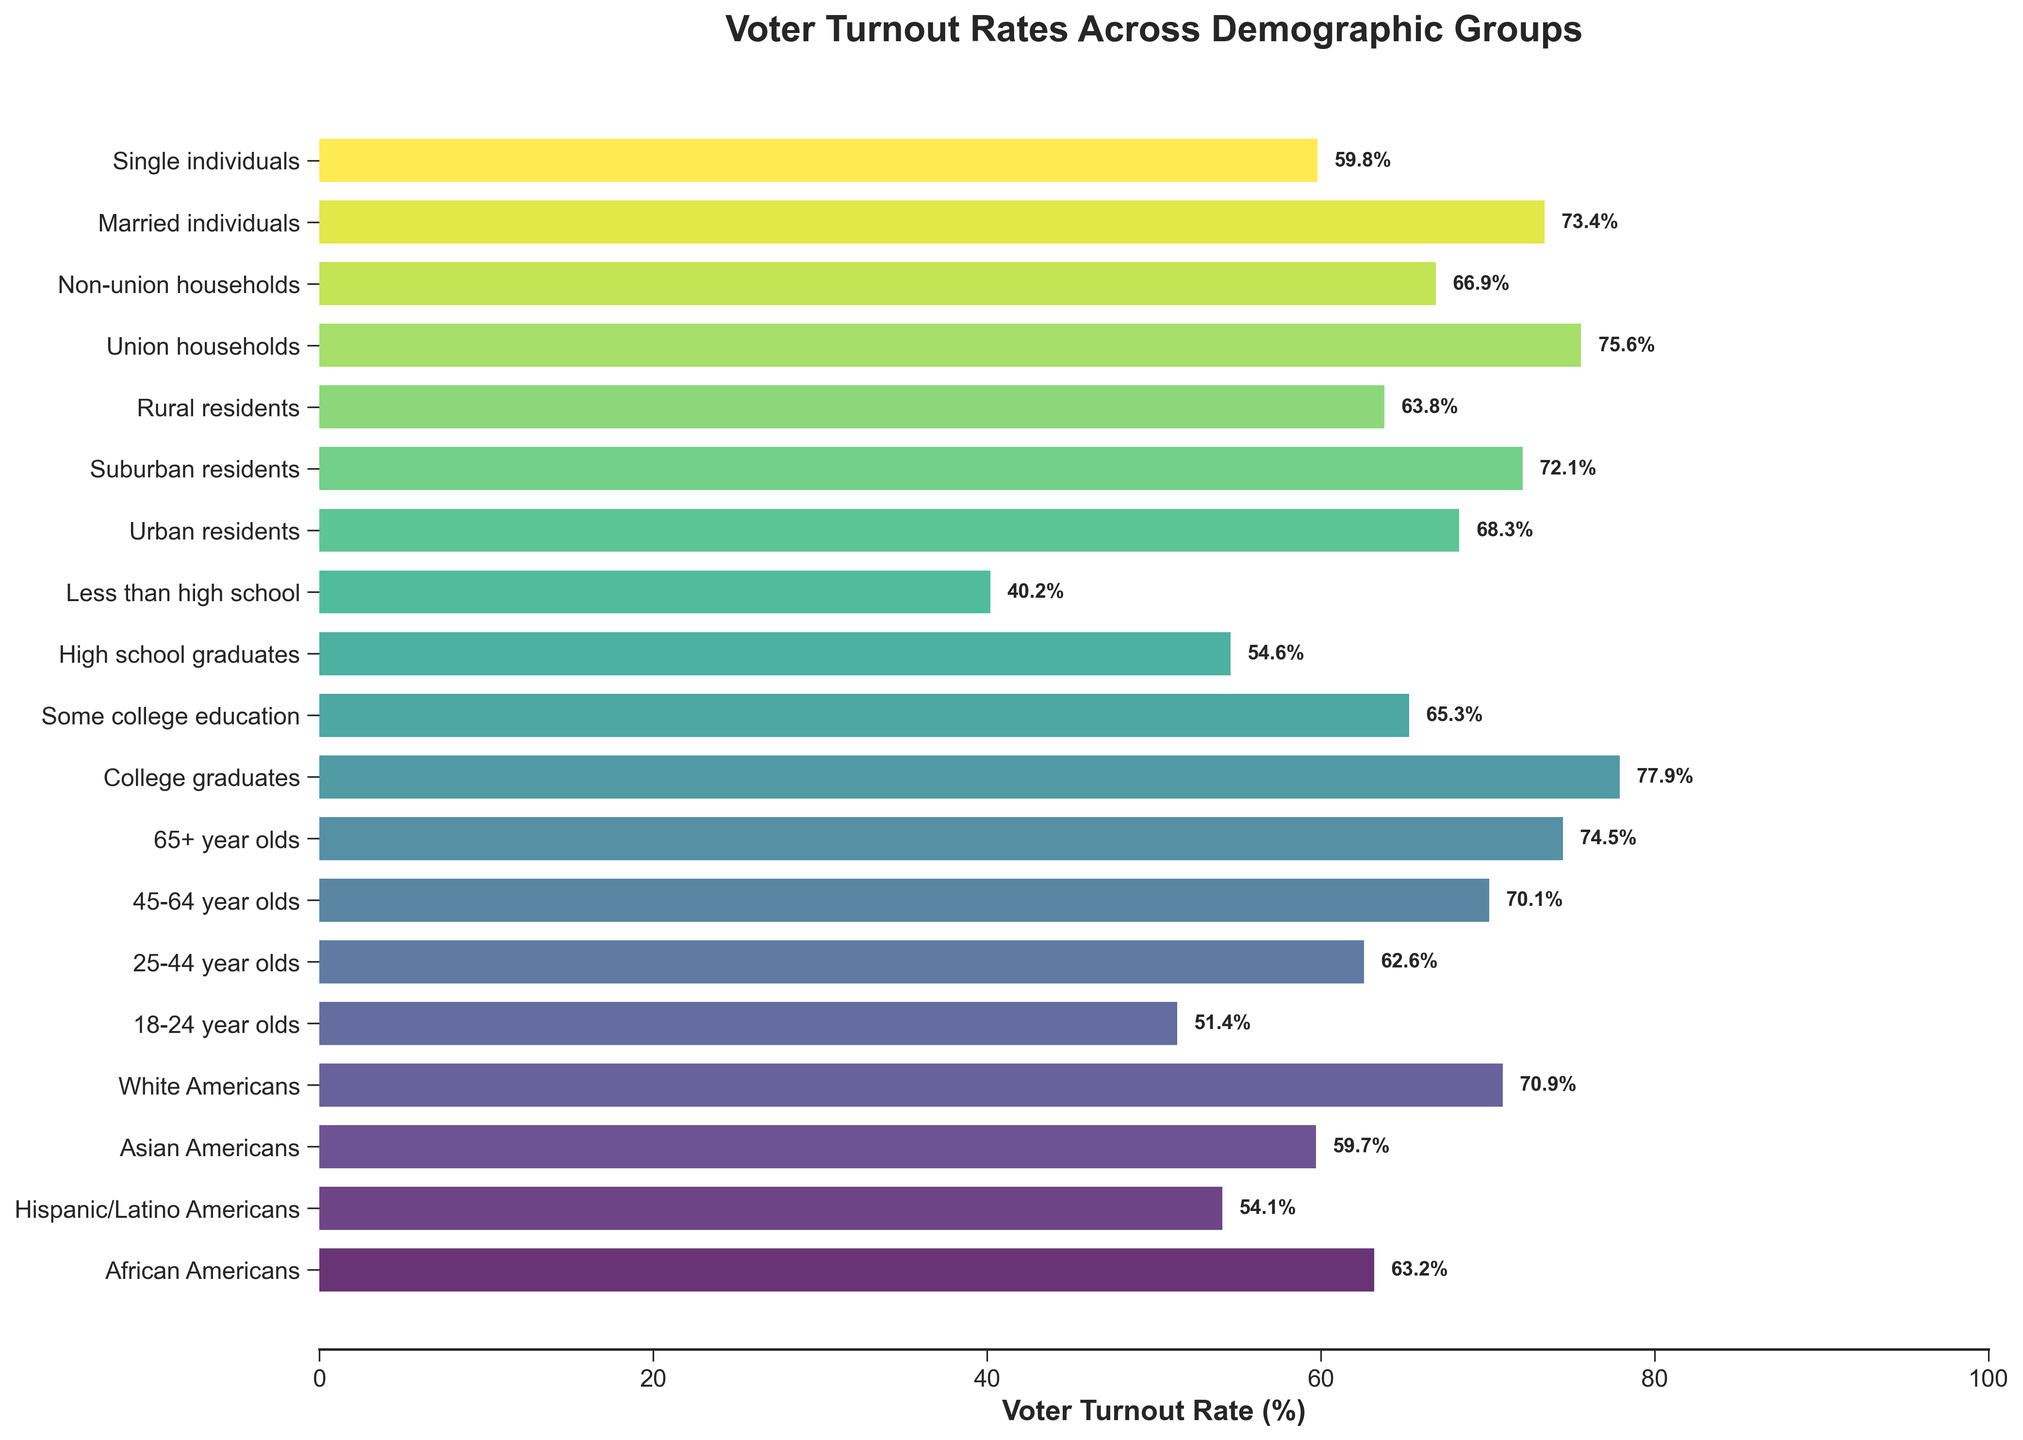What demographic group has the highest voter turnout rate? The bar representing "College graduates" is the longest, extending to 77.9%.
Answer: College graduates Which two demographic groups have the lowest voter turnout rates? The bars representing "Less than high school" and "18-24 year olds" are the shortest, extending to 40.2% and 51.4%, respectively.
Answer: Less than high school, 18-24 year olds What is the difference in voter turnout rate between African Americans and White Americans? The bar for African Americans has a length of 63.2%, and the bar for White Americans has a length of 70.9%. The difference is 70.9% - 63.2% = 7.7%.
Answer: 7.7% What is the average voter turnout rate of all groups? Sum all the voter turnout rates and divide by the number of groups: (63.2 + 54.1 + 59.7 + 70.9 + 51.4 + 62.6 + 70.1 + 74.5 + 77.9 + 65.3 + 54.6 + 40.2 + 68.3 + 72.1 + 63.8 + 75.6 + 66.9 + 73.4 + 59.8) / 19 = 64.7%.
Answer: 64.7% Which demographic group has the highest voter turnout rate among age groups? The bar for "65+ year olds" is the longest among age groups, extending to 74.5%.
Answer: 65+ year olds Among urban, suburban, and rural residents, who has the highest voter turnout rate? The bar representing suburban residents is the longest among the three groups, extending to 72.1%.
Answer: Suburban residents How much higher is the voter turnout rate for union households compared to non-union households? The bar for union households extends to 75.6%, and the bar for non-union households extends to 66.9%. The difference is 75.6% - 66.9% = 8.7%.
Answer: 8.7% What is the median voter turnout rate across all groups? Arrange the voter turnout rates in ascending order: [40.2, 51.4, 54.1, 54.6, 59.7, 59.8, 62.6, 63.2, 63.8, 65.3, 66.9, 68.3, 70.1, 70.9, 72.1, 73.4, 74.5, 75.6, 77.9]. The median is the 10th value, 65.3%.
Answer: 65.3% Is the voter turnout rate of single individuals higher or lower than that of married individuals? The bar for single individuals extends to 59.8%, while the bar for married individuals extends to 73.4%. 59.8% is lower than 73.4%.
Answer: Lower Which educational attainment group has the lowest voter turnout rate? The bar for "Less than high school" is the shortest among educational attainment groups, extending to 40.2%.
Answer: Less than high school 